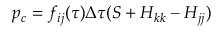<formula> <loc_0><loc_0><loc_500><loc_500>p _ { c } = f _ { i j } ( \tau ) \Delta \tau ( S + H _ { k k } - H _ { j j } )</formula> 